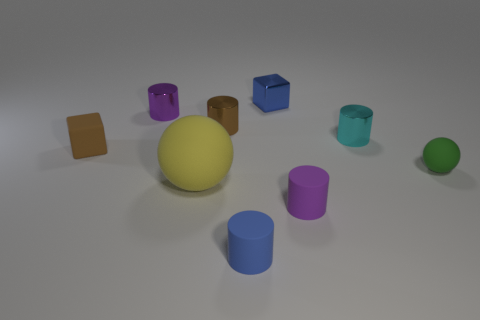What is the size of the purple shiny object?
Your answer should be compact. Small. There is a purple metal thing; is it the same size as the matte sphere left of the green matte thing?
Offer a very short reply. No. There is a block left of the cube behind the purple thing behind the tiny green matte object; what color is it?
Your response must be concise. Brown. Is the material of the small purple cylinder on the right side of the small brown metal cylinder the same as the cyan thing?
Provide a short and direct response. No. How many other things are there of the same material as the big yellow sphere?
Your answer should be very brief. 4. There is a blue block that is the same size as the brown cylinder; what is its material?
Your response must be concise. Metal. Does the small blue thing behind the green matte thing have the same shape as the metal thing to the right of the small purple matte cylinder?
Your response must be concise. No. The green object that is the same size as the blue block is what shape?
Provide a short and direct response. Sphere. Do the small purple thing that is on the left side of the blue matte cylinder and the cube that is on the left side of the small brown shiny object have the same material?
Offer a very short reply. No. Are there any brown rubber blocks behind the small rubber block that is in front of the brown metal cylinder?
Make the answer very short. No. 